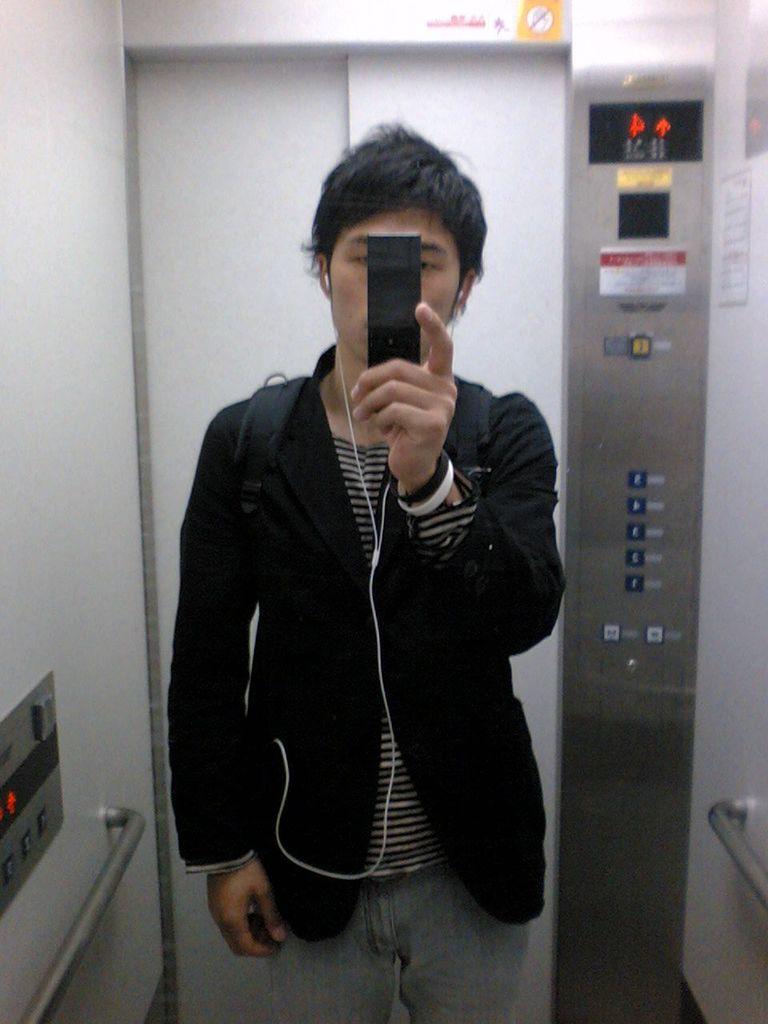Please provide a concise description of this image. In this image I can see a man is standing in a lift. The man is holding an object in the hand. In the background I can see a metal rod, buttons and other objects. 